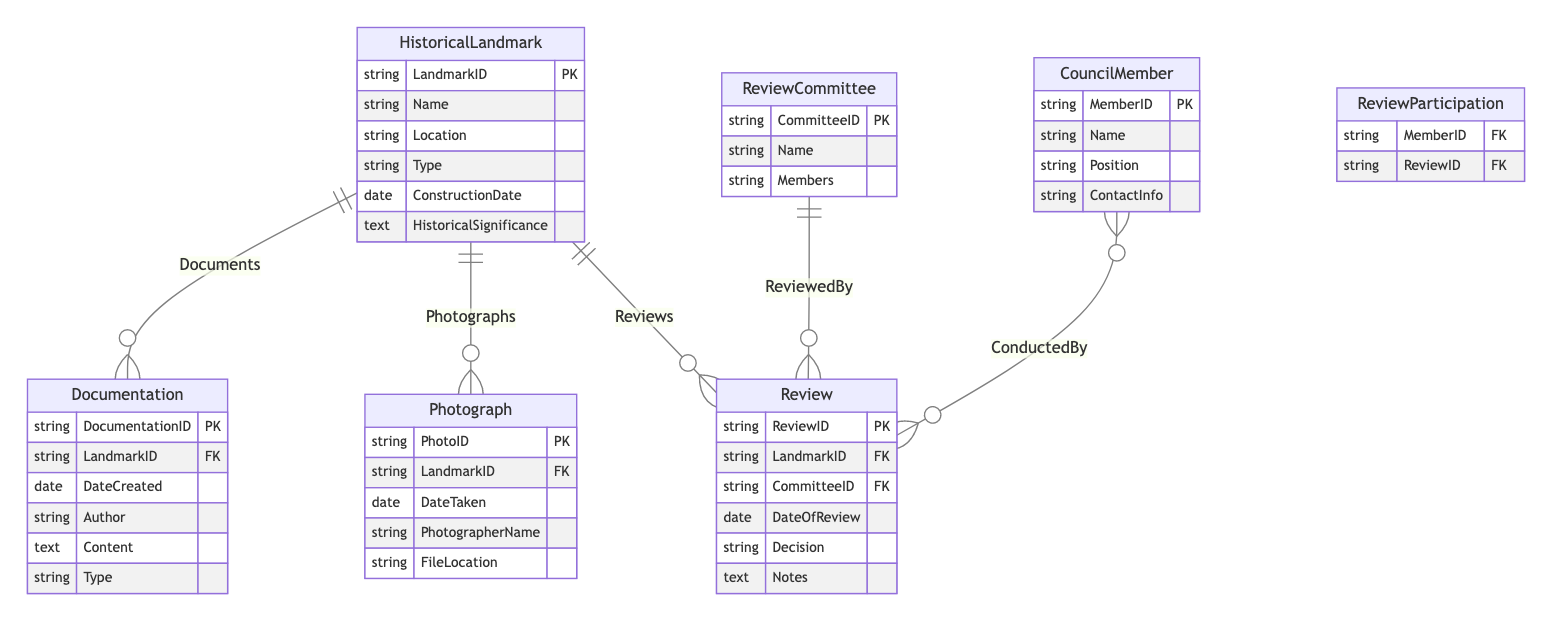What's the primary key of the HistoricalLandmark entity? The primary key for the HistoricalLandmark entity is LandmarkID, which uniquely identifies each historical landmark in the database.
Answer: LandmarkID How many relationships are connecting the HistoricalLandmark entity? There are three relationships connecting the HistoricalLandmark entity: Documents, Photographs, and Reviews. Each of these relationships represents a connection to another entity.
Answer: Three What type of relationship exists between ReviewCommittee and Review? The relationship between ReviewCommittee and Review is a one-to-many relationship, indicating that one review committee can review multiple reviews.
Answer: One-to-many Which entity documents the historical landmarks? The Documentation entity is responsible for documenting the historical landmarks, containing details related to each landmark.
Answer: Documentation How many attributes does the CouncilMember entity have? The CouncilMember entity has four attributes, which are MemberID, Name, Position, and ContactInfo. These attributes provide necessary details about each council member.
Answer: Four What is the junction table used in the relationship between CouncilMember and Review? The junction table used in the relationship between CouncilMember and Review is named ReviewParticipation. This table facilitates the many-to-many relationship between these two entities.
Answer: ReviewParticipation Which attribute in the Review entity records the date the review took place? The attribute that records the date the review took place in the Review entity is DateOfReview, providing a timestamp for when each review is conducted.
Answer: DateOfReview In the Review entity, what does the Decision attribute represent? The Decision attribute in the Review entity represents the outcome of the review process, indicating whether a landmark was approved, denied, or conditionally approved.
Answer: Decision What does the Photographs relationship indicate about HistoricalLandmark? The Photographs relationship indicates that each HistoricalLandmark can have multiple photographs associated with it, showcasing different aspects or views of the landmark.
Answer: Multiple photographs 